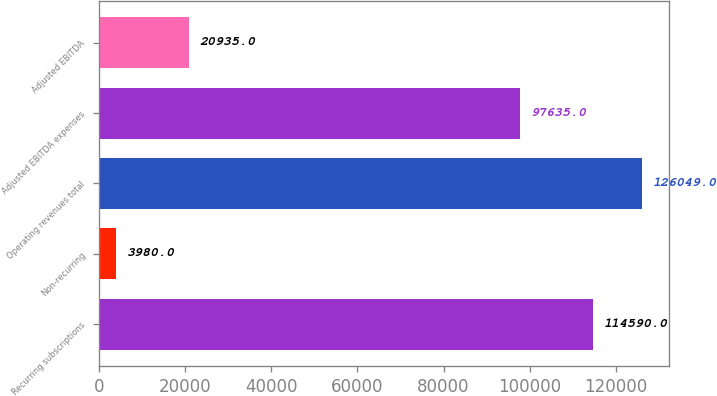<chart> <loc_0><loc_0><loc_500><loc_500><bar_chart><fcel>Recurring subscriptions<fcel>Non-recurring<fcel>Operating revenues total<fcel>Adjusted EBITDA expenses<fcel>Adjusted EBITDA<nl><fcel>114590<fcel>3980<fcel>126049<fcel>97635<fcel>20935<nl></chart> 